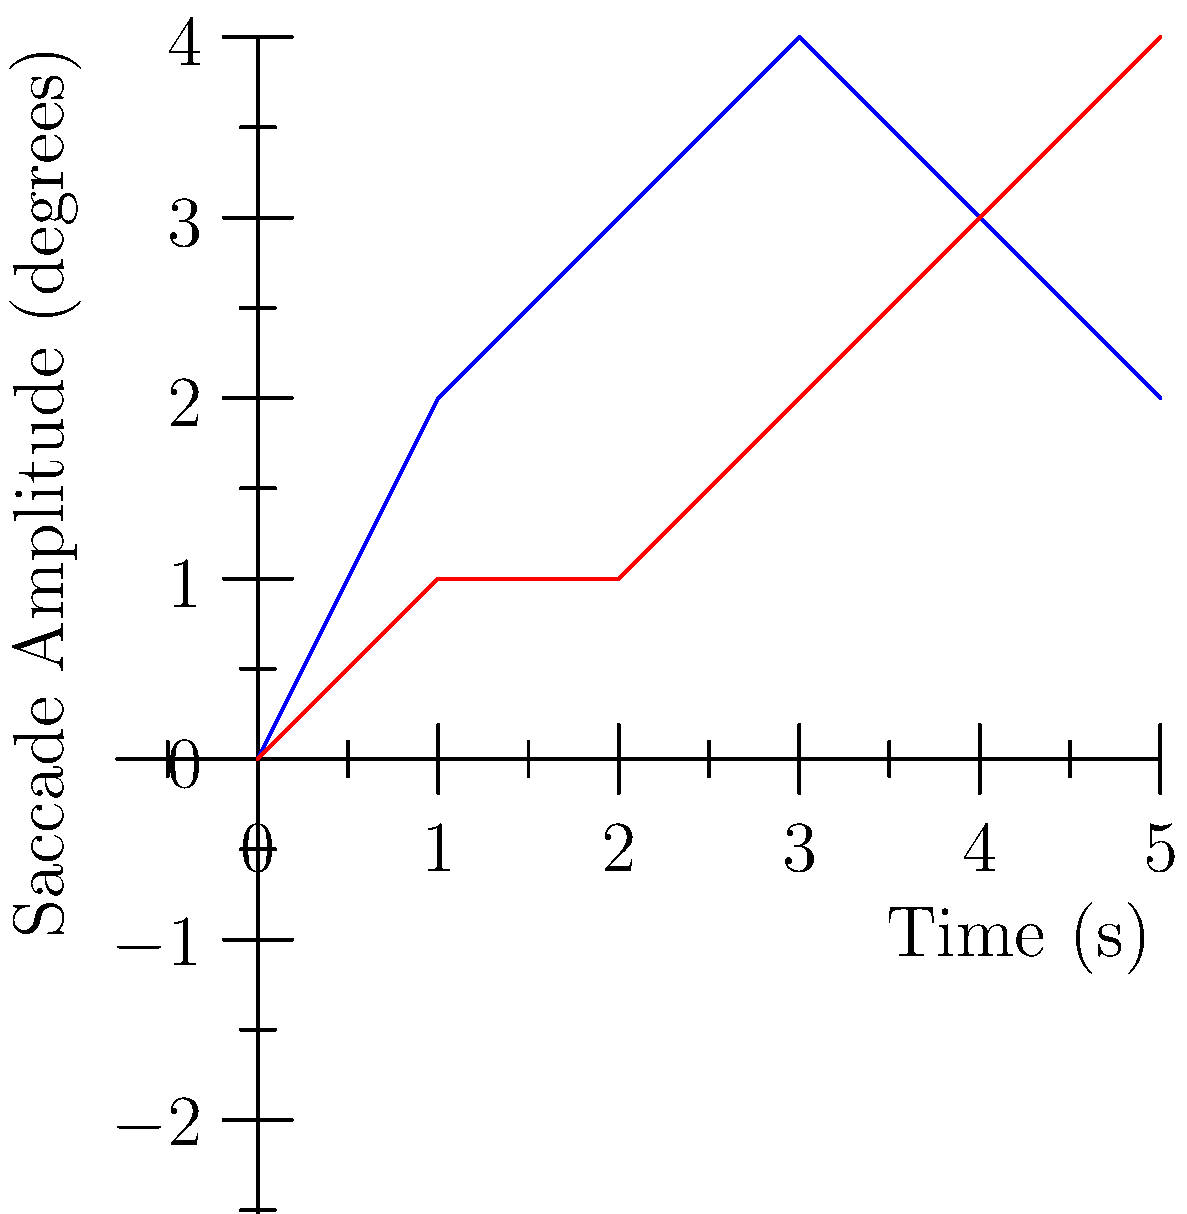Based on the eye movement patterns shown in the graph, which of the following statements is most likely true about religious vision experiences compared to control conditions?

A) They involve more rapid and frequent saccades
B) They show consistently lower saccade amplitudes
C) They exhibit no difference in eye movement patterns
D) They demonstrate longer fixation durations To answer this question, we need to analyze the graph and understand what it represents:

1. The x-axis shows time in seconds, while the y-axis represents saccade amplitude in degrees.
2. Saccades are rapid eye movements between fixation points.
3. The blue line represents eye movements during religious vision experiences, while the red line represents the control condition.

Let's examine each option:

A) They involve more rapid and frequent saccades:
   - The blue line (religious vision) shows higher peaks and more variation in amplitude compared to the red line (control).
   - This suggests more rapid and frequent changes in eye position, indicating more saccades.

B) They show consistently lower saccade amplitudes:
   - The blue line is generally higher than the red line, indicating larger saccade amplitudes for religious visions.
   - This option is incorrect.

C) They exhibit no difference in eye movement patterns:
   - There are clear differences between the two lines, so this option is incorrect.

D) They demonstrate longer fixation durations:
   - Fixation durations are not directly represented in this graph.
   - We cannot conclude anything about fixation durations from the given data.

Based on the graph, option A is the most likely to be true. The religious vision experience (blue line) shows higher peaks and more variation in saccade amplitude over time, suggesting more rapid and frequent saccades compared to the control condition.
Answer: A) They involve more rapid and frequent saccades 